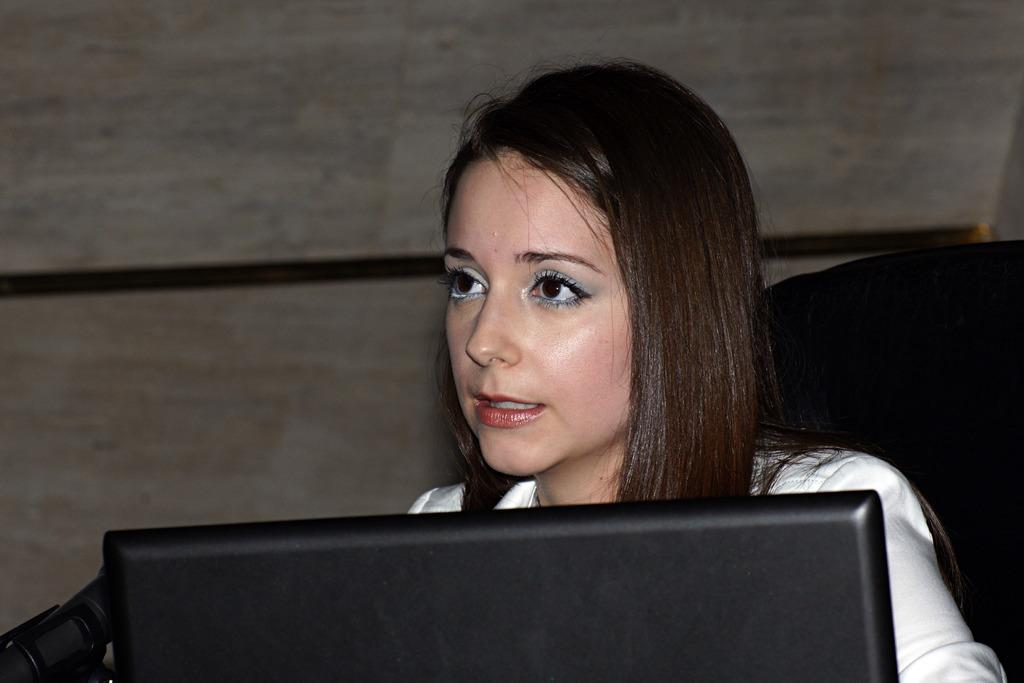What is the appearance of the person in the image? There is a beautiful lady in the image. What is the lady wearing? The lady is wearing a white dress. What is the lady doing in the image? The lady is sitting on a chair. What is the lady holding in the image? The lady is holding a device. What type of flowers can be seen in the lady's hair in the image? There are no flowers visible in the lady's hair in the image. What tools might the carpenter be using in the image? There is no carpenter present in the image, so it is not possible to determine what tools they might be using. 